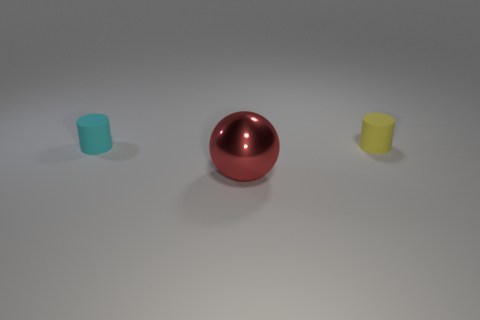Are the small yellow object and the cyan cylinder in front of the small yellow cylinder made of the same material?
Offer a terse response. Yes. There is a matte thing on the right side of the thing that is in front of the tiny rubber object that is to the left of the big metal thing; what is its color?
Your answer should be compact. Yellow. Are there any other things that are the same size as the ball?
Offer a very short reply. No. There is a large ball; does it have the same color as the matte cylinder that is on the right side of the red shiny object?
Keep it short and to the point. No. What is the color of the large sphere?
Your response must be concise. Red. There is a big shiny thing that is left of the small yellow object that is right of the thing on the left side of the large metal sphere; what shape is it?
Your response must be concise. Sphere. How many other things are there of the same color as the big ball?
Offer a terse response. 0. Is the number of cyan things that are left of the red metallic ball greater than the number of large objects on the right side of the tiny yellow rubber object?
Give a very brief answer. Yes. There is a tiny cyan cylinder; are there any small matte cylinders behind it?
Provide a short and direct response. Yes. What is the object that is in front of the tiny yellow cylinder and right of the cyan rubber cylinder made of?
Keep it short and to the point. Metal. 